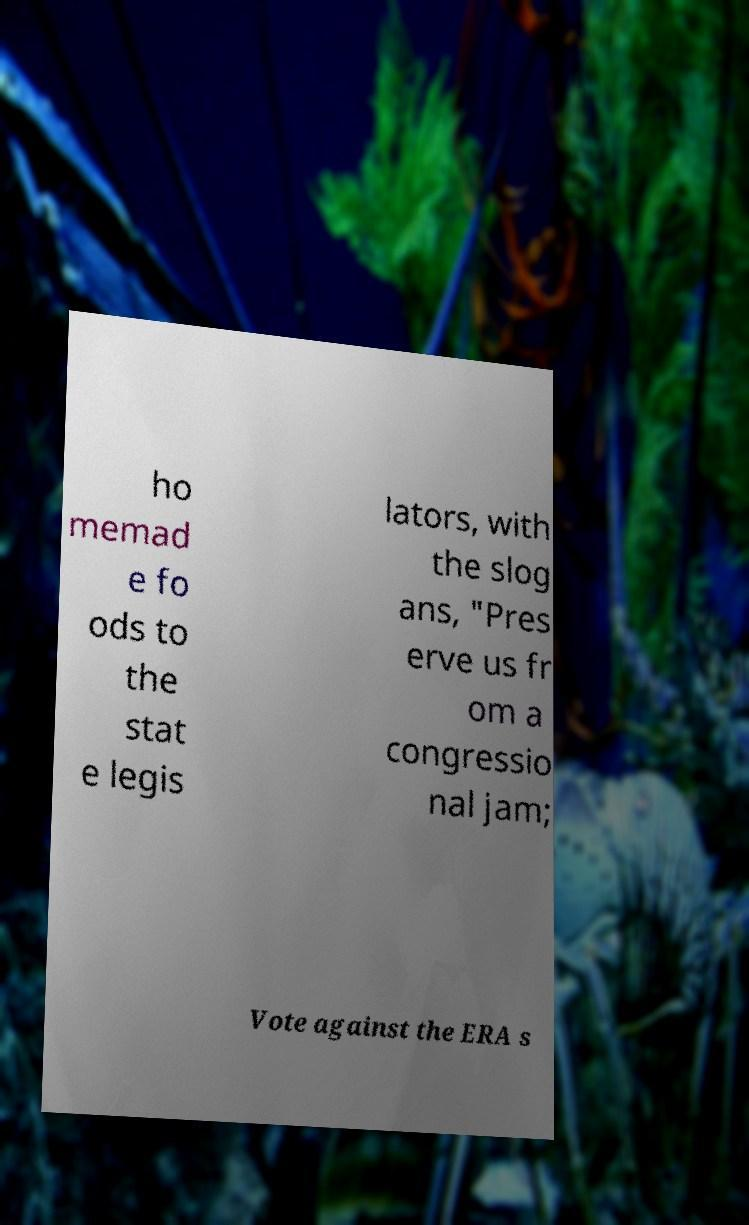Can you accurately transcribe the text from the provided image for me? ho memad e fo ods to the stat e legis lators, with the slog ans, "Pres erve us fr om a congressio nal jam; Vote against the ERA s 